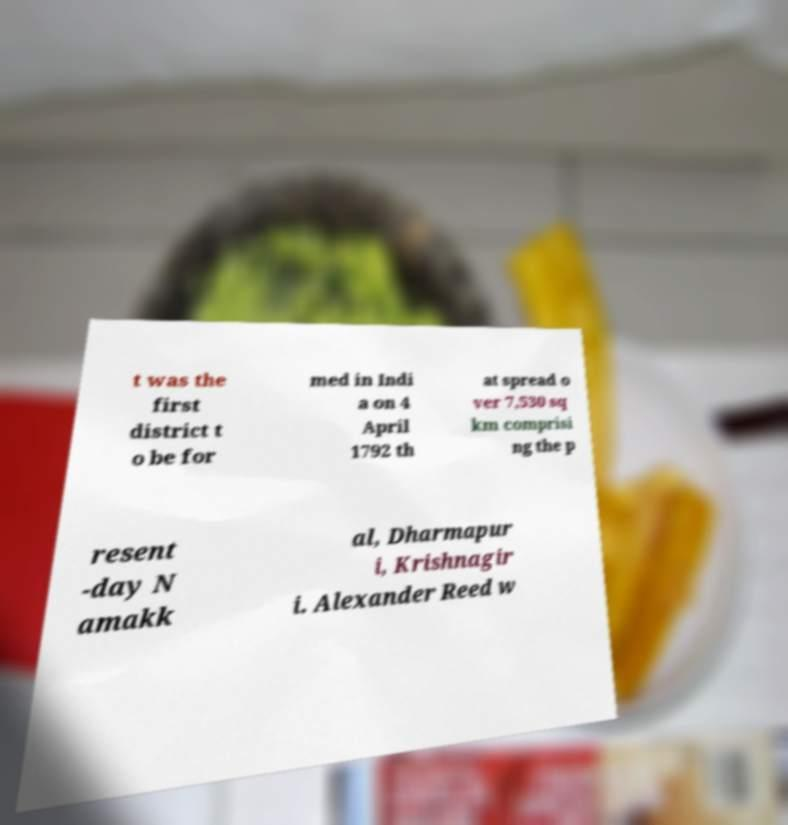I need the written content from this picture converted into text. Can you do that? t was the first district t o be for med in Indi a on 4 April 1792 th at spread o ver 7,530 sq km comprisi ng the p resent -day N amakk al, Dharmapur i, Krishnagir i. Alexander Reed w 